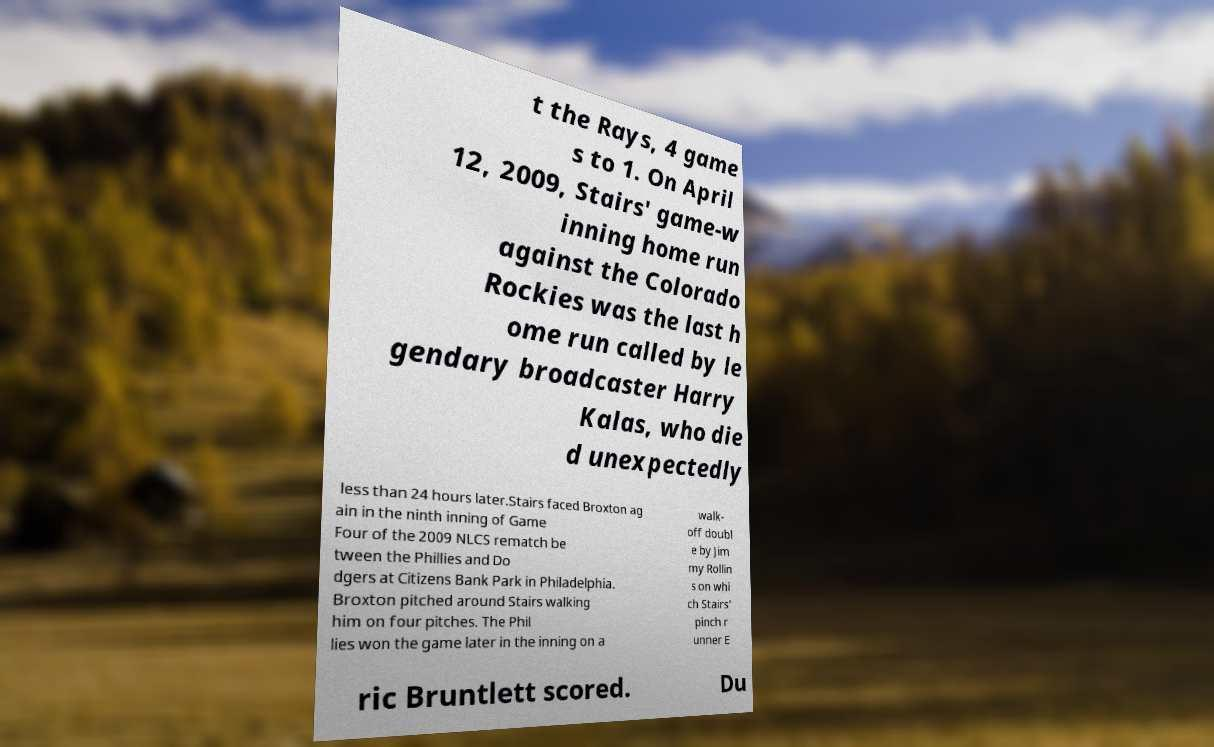Can you accurately transcribe the text from the provided image for me? t the Rays, 4 game s to 1. On April 12, 2009, Stairs' game-w inning home run against the Colorado Rockies was the last h ome run called by le gendary broadcaster Harry Kalas, who die d unexpectedly less than 24 hours later.Stairs faced Broxton ag ain in the ninth inning of Game Four of the 2009 NLCS rematch be tween the Phillies and Do dgers at Citizens Bank Park in Philadelphia. Broxton pitched around Stairs walking him on four pitches. The Phil lies won the game later in the inning on a walk- off doubl e by Jim my Rollin s on whi ch Stairs' pinch r unner E ric Bruntlett scored. Du 